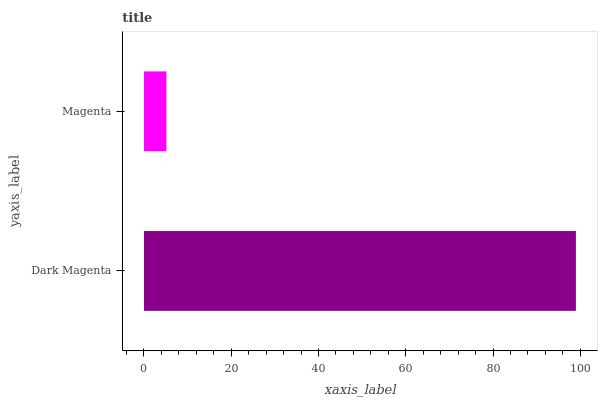Is Magenta the minimum?
Answer yes or no. Yes. Is Dark Magenta the maximum?
Answer yes or no. Yes. Is Magenta the maximum?
Answer yes or no. No. Is Dark Magenta greater than Magenta?
Answer yes or no. Yes. Is Magenta less than Dark Magenta?
Answer yes or no. Yes. Is Magenta greater than Dark Magenta?
Answer yes or no. No. Is Dark Magenta less than Magenta?
Answer yes or no. No. Is Dark Magenta the high median?
Answer yes or no. Yes. Is Magenta the low median?
Answer yes or no. Yes. Is Magenta the high median?
Answer yes or no. No. Is Dark Magenta the low median?
Answer yes or no. No. 